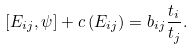Convert formula to latex. <formula><loc_0><loc_0><loc_500><loc_500>\left [ E _ { i j } , \psi \right ] + c \left ( E _ { i j } \right ) = b _ { i j } \frac { t _ { i } } { t _ { j } } .</formula> 